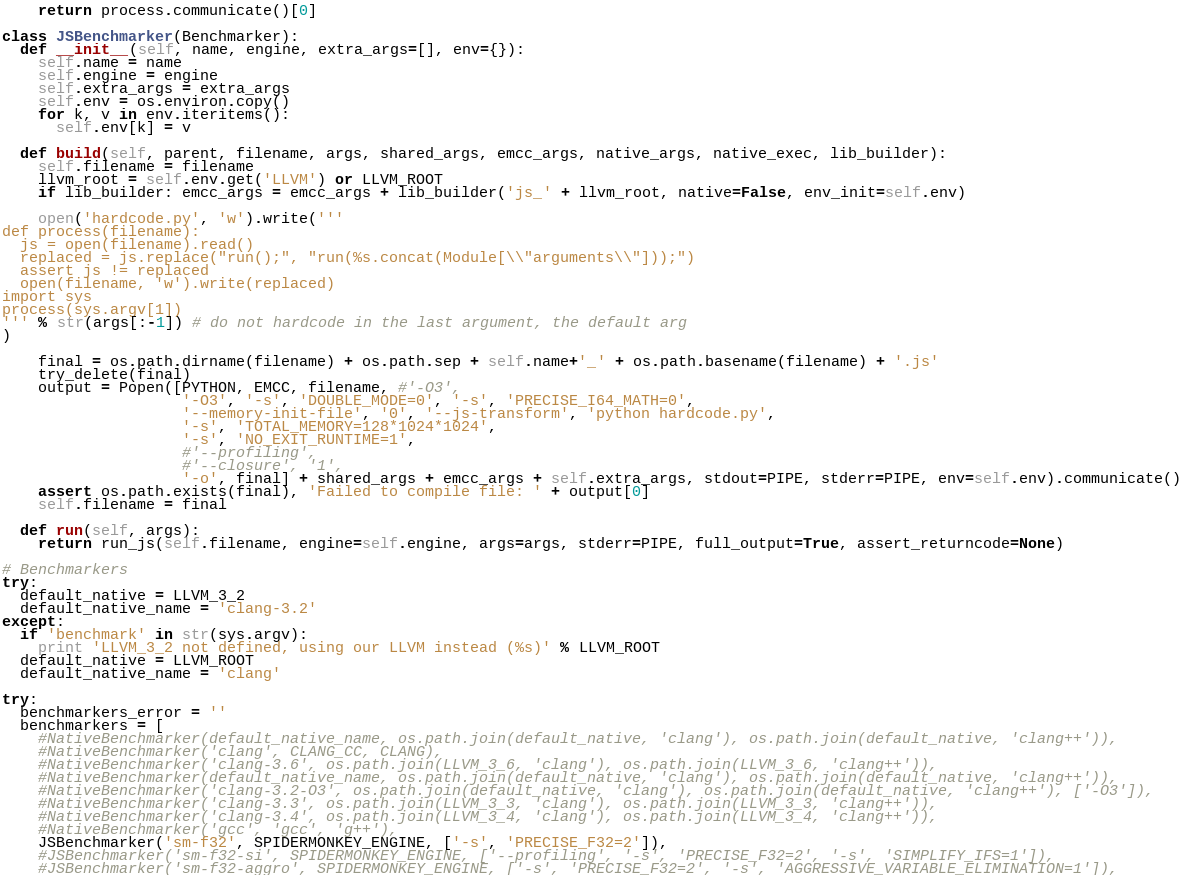<code> <loc_0><loc_0><loc_500><loc_500><_Python_>    return process.communicate()[0]

class JSBenchmarker(Benchmarker):
  def __init__(self, name, engine, extra_args=[], env={}):
    self.name = name
    self.engine = engine
    self.extra_args = extra_args
    self.env = os.environ.copy()
    for k, v in env.iteritems():
      self.env[k] = v

  def build(self, parent, filename, args, shared_args, emcc_args, native_args, native_exec, lib_builder):
    self.filename = filename
    llvm_root = self.env.get('LLVM') or LLVM_ROOT
    if lib_builder: emcc_args = emcc_args + lib_builder('js_' + llvm_root, native=False, env_init=self.env)

    open('hardcode.py', 'w').write('''
def process(filename):
  js = open(filename).read()
  replaced = js.replace("run();", "run(%s.concat(Module[\\"arguments\\"]));")
  assert js != replaced
  open(filename, 'w').write(replaced)
import sys
process(sys.argv[1])
''' % str(args[:-1]) # do not hardcode in the last argument, the default arg
)

    final = os.path.dirname(filename) + os.path.sep + self.name+'_' + os.path.basename(filename) + '.js'
    try_delete(final)
    output = Popen([PYTHON, EMCC, filename, #'-O3',
                    '-O3', '-s', 'DOUBLE_MODE=0', '-s', 'PRECISE_I64_MATH=0',
                    '--memory-init-file', '0', '--js-transform', 'python hardcode.py',
                    '-s', 'TOTAL_MEMORY=128*1024*1024',
                    '-s', 'NO_EXIT_RUNTIME=1',
                    #'--profiling',
                    #'--closure', '1',
                    '-o', final] + shared_args + emcc_args + self.extra_args, stdout=PIPE, stderr=PIPE, env=self.env).communicate()
    assert os.path.exists(final), 'Failed to compile file: ' + output[0]
    self.filename = final

  def run(self, args):
    return run_js(self.filename, engine=self.engine, args=args, stderr=PIPE, full_output=True, assert_returncode=None)

# Benchmarkers
try:
  default_native = LLVM_3_2
  default_native_name = 'clang-3.2'
except:
  if 'benchmark' in str(sys.argv):
    print 'LLVM_3_2 not defined, using our LLVM instead (%s)' % LLVM_ROOT
  default_native = LLVM_ROOT
  default_native_name = 'clang'

try:
  benchmarkers_error = ''
  benchmarkers = [
    #NativeBenchmarker(default_native_name, os.path.join(default_native, 'clang'), os.path.join(default_native, 'clang++')),
    #NativeBenchmarker('clang', CLANG_CC, CLANG),
    #NativeBenchmarker('clang-3.6', os.path.join(LLVM_3_6, 'clang'), os.path.join(LLVM_3_6, 'clang++')),
    #NativeBenchmarker(default_native_name, os.path.join(default_native, 'clang'), os.path.join(default_native, 'clang++')),
    #NativeBenchmarker('clang-3.2-O3', os.path.join(default_native, 'clang'), os.path.join(default_native, 'clang++'), ['-O3']),
    #NativeBenchmarker('clang-3.3', os.path.join(LLVM_3_3, 'clang'), os.path.join(LLVM_3_3, 'clang++')),
    #NativeBenchmarker('clang-3.4', os.path.join(LLVM_3_4, 'clang'), os.path.join(LLVM_3_4, 'clang++')),
    #NativeBenchmarker('gcc', 'gcc', 'g++'),
    JSBenchmarker('sm-f32', SPIDERMONKEY_ENGINE, ['-s', 'PRECISE_F32=2']),
    #JSBenchmarker('sm-f32-si', SPIDERMONKEY_ENGINE, ['--profiling', '-s', 'PRECISE_F32=2', '-s', 'SIMPLIFY_IFS=1']),
    #JSBenchmarker('sm-f32-aggro', SPIDERMONKEY_ENGINE, ['-s', 'PRECISE_F32=2', '-s', 'AGGRESSIVE_VARIABLE_ELIMINATION=1']),</code> 